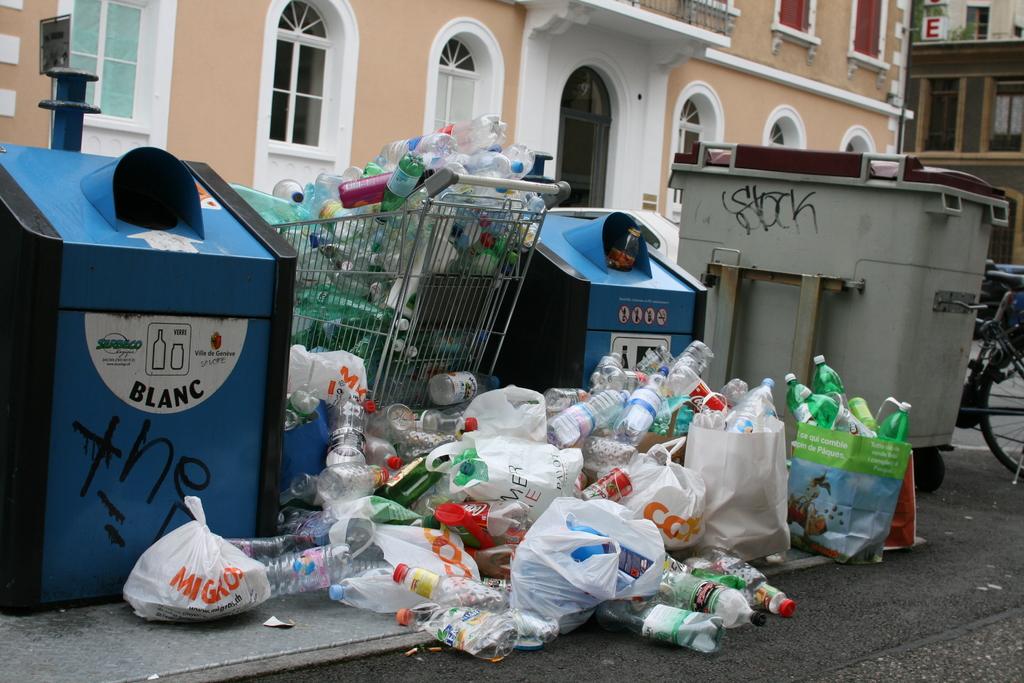What is written on the blue bin?
Your answer should be compact. Blanc. 